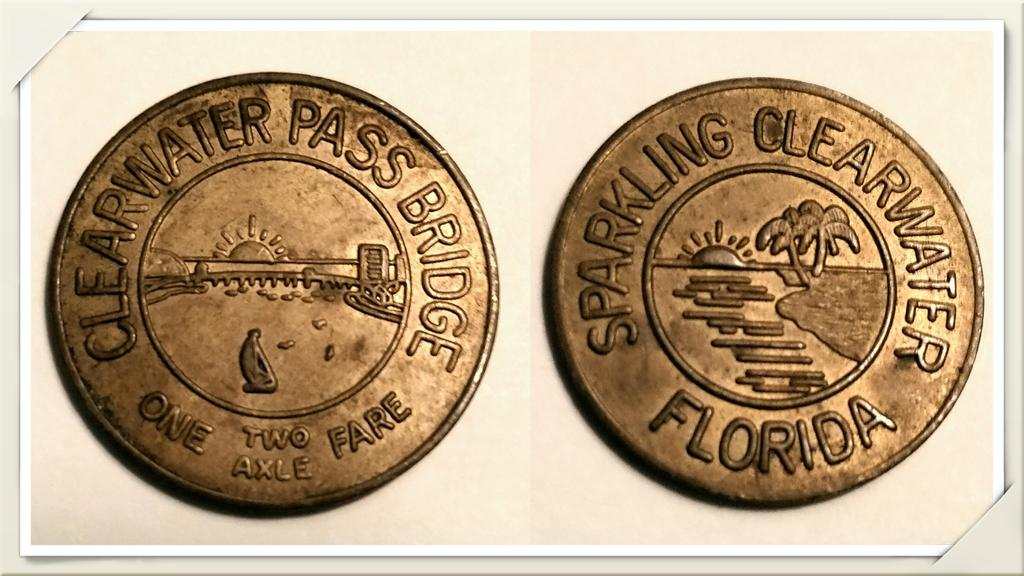<image>
Offer a succinct explanation of the picture presented. Two Clearwater Pass Bridge coins show both sides of the coin. 